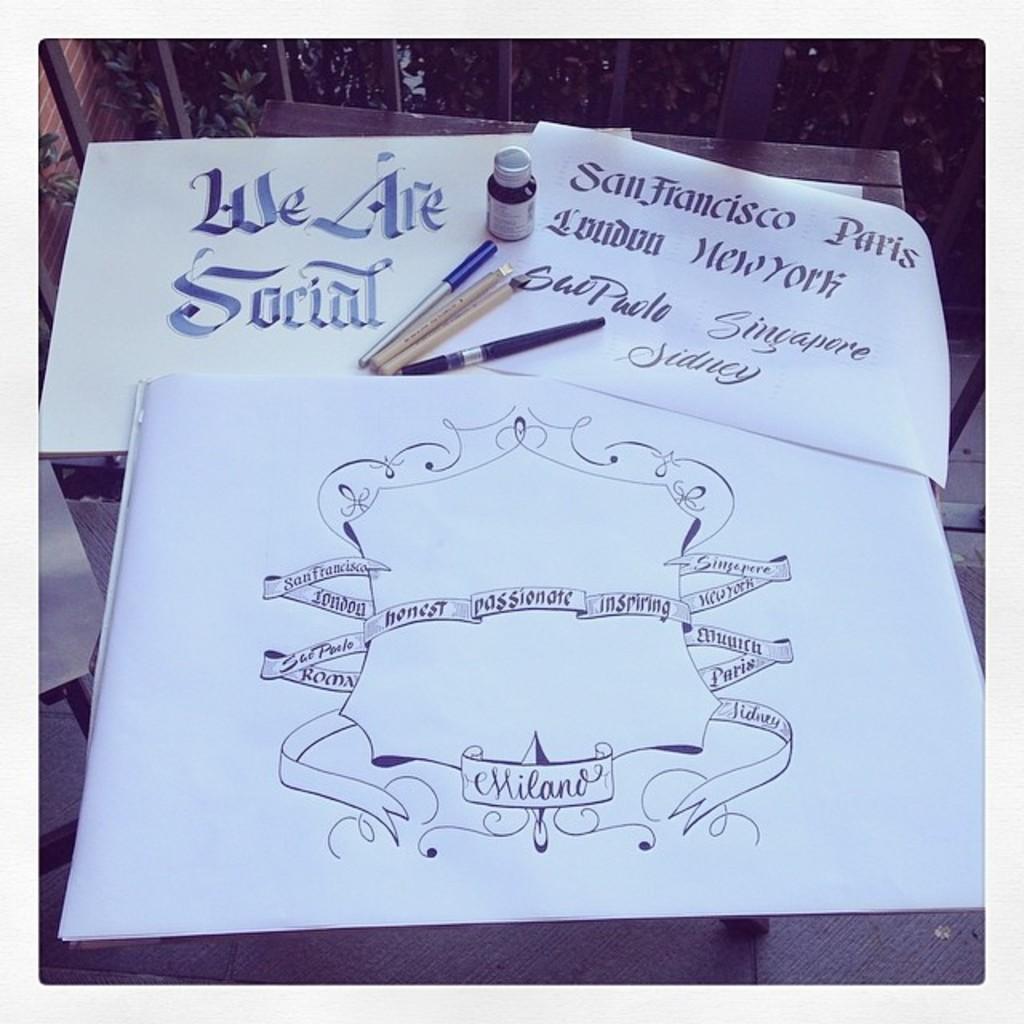Describe this image in one or two sentences. In this image we can see papers, pens and bottle placed on a wooden surface. In the papers we can see some text and on the bottle there is a label. At the top we can see plants and metal fencing. 